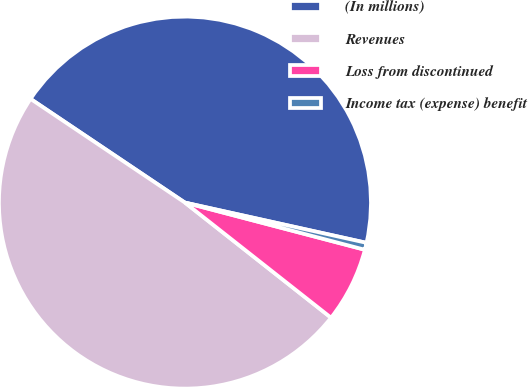Convert chart. <chart><loc_0><loc_0><loc_500><loc_500><pie_chart><fcel>(In millions)<fcel>Revenues<fcel>Loss from discontinued<fcel>Income tax (expense) benefit<nl><fcel>44.06%<fcel>48.8%<fcel>6.54%<fcel>0.61%<nl></chart> 